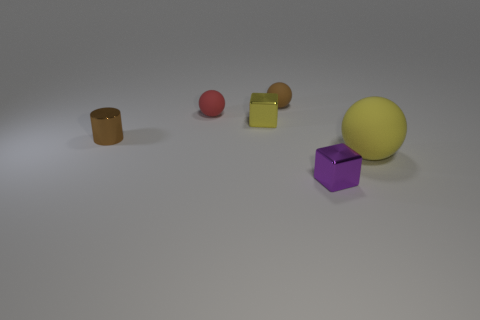Are there any other things that have the same size as the yellow matte object?
Your answer should be very brief. No. Is the number of metal objects that are to the left of the red rubber sphere greater than the number of tiny yellow rubber blocks?
Make the answer very short. Yes. What shape is the tiny purple object that is the same material as the brown cylinder?
Your answer should be compact. Cube. There is a metallic thing that is in front of the thing that is on the right side of the purple cube; what is its color?
Your response must be concise. Purple. Is the small brown matte thing the same shape as the big matte object?
Offer a very short reply. Yes. There is a red thing that is the same shape as the big yellow thing; what material is it?
Your answer should be compact. Rubber. There is a yellow thing on the left side of the matte object that is on the right side of the brown matte thing; are there any small shiny objects that are on the left side of it?
Provide a succinct answer. Yes. Do the yellow matte object and the rubber object behind the red object have the same shape?
Make the answer very short. Yes. Does the sphere right of the small purple metal block have the same color as the metallic block that is behind the big matte object?
Provide a short and direct response. Yes. Are any green metallic cubes visible?
Make the answer very short. No. 